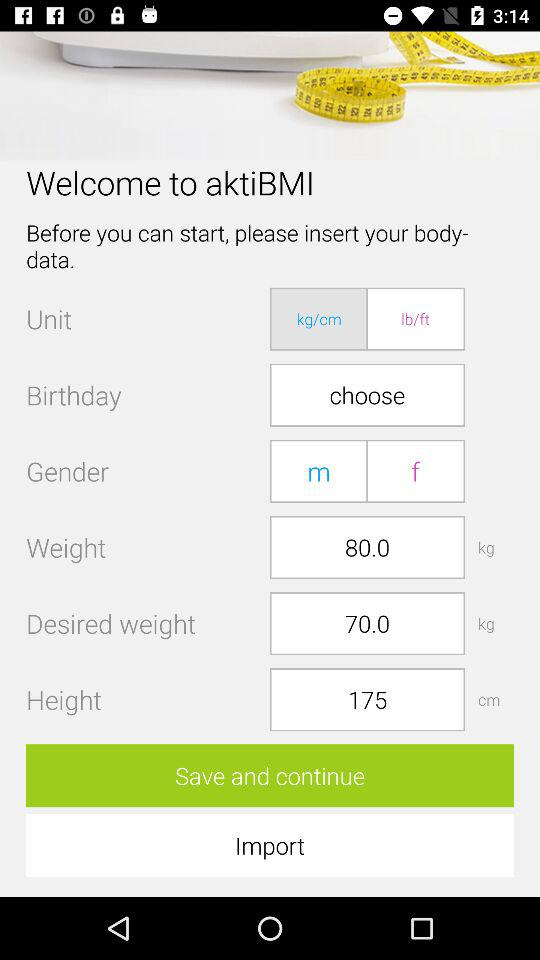What is the desired weight? The desired weight is 70 kg. 